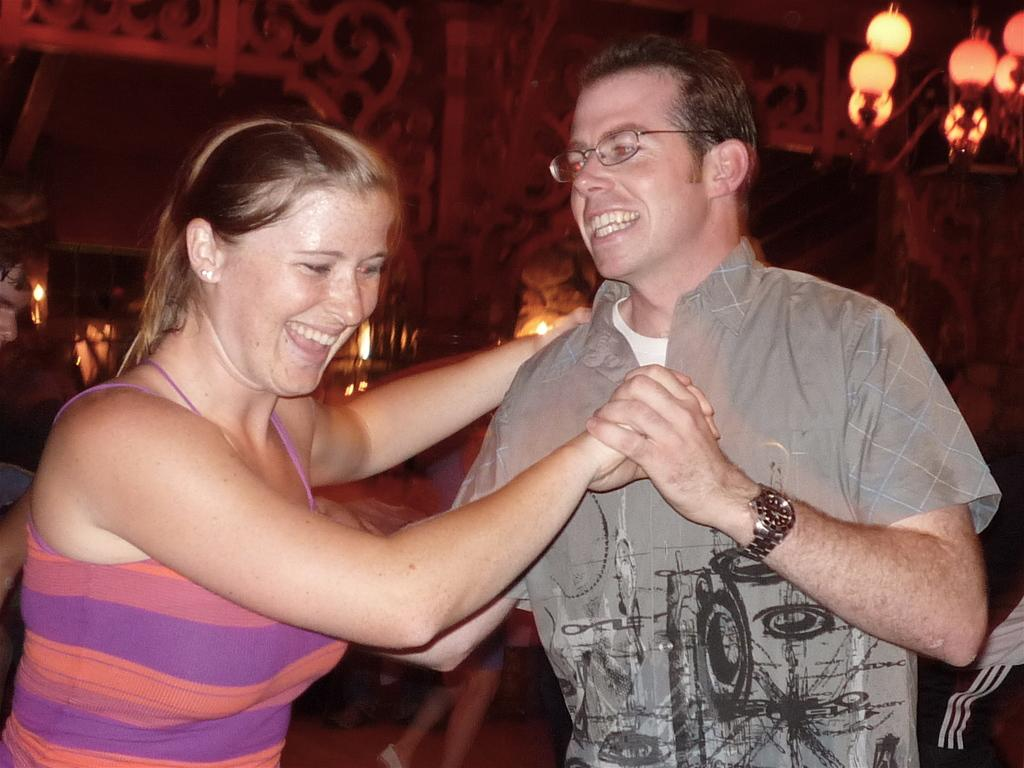What is the gender of the person in the image? There is a man in the image. Can you describe any accessories the man is wearing? The man is wearing spectacles and a watch. What is the man doing with his hand in the image? The man is holding a woman's hand. How are the man and the woman depicted in the image? Both the man and the woman are smiling. What can be seen in the background of the image? There are lights visible in the background of the image. What type of machine is the man operating in the image? There is no machine present in the image; it features a man holding a woman's hand and smiling. What is the reaction of the chain to the man's actions in the image? There is no chain present in the image, and therefore no reaction can be observed. 